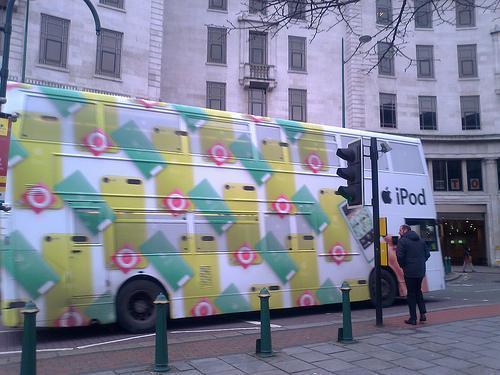How many buses are in the image?
Give a very brief answer. 1. 